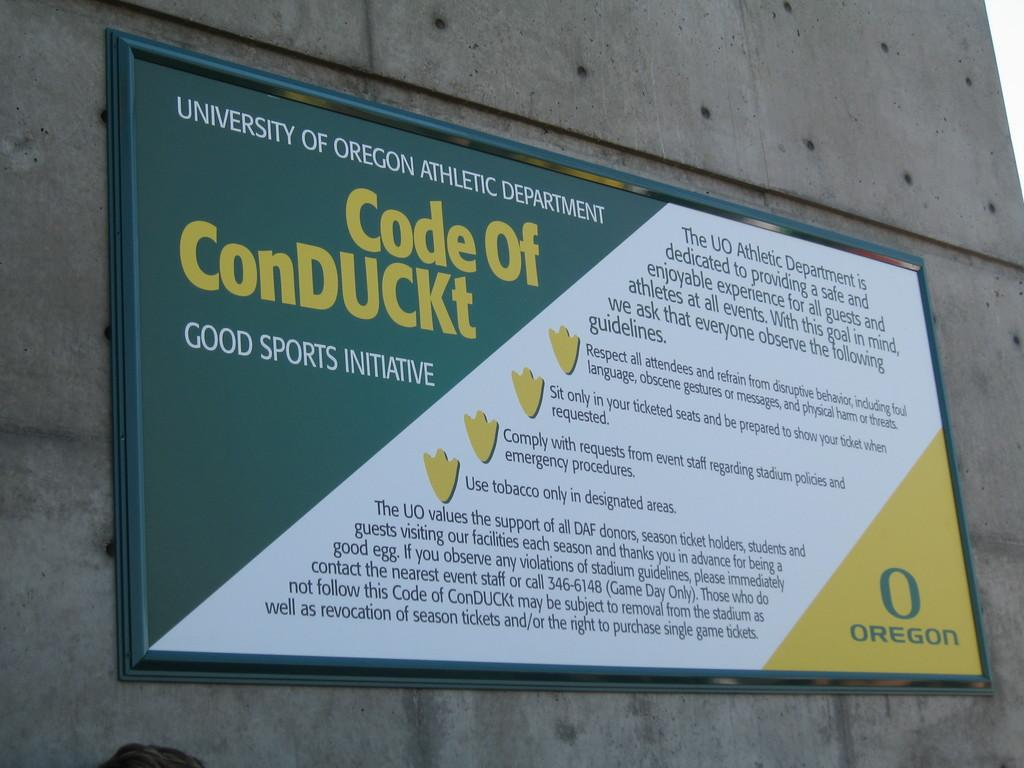Provide a one-sentence caption for the provided image. A sign for the University of Oregon Athletic Department displays a Code of ConDUCKt. 